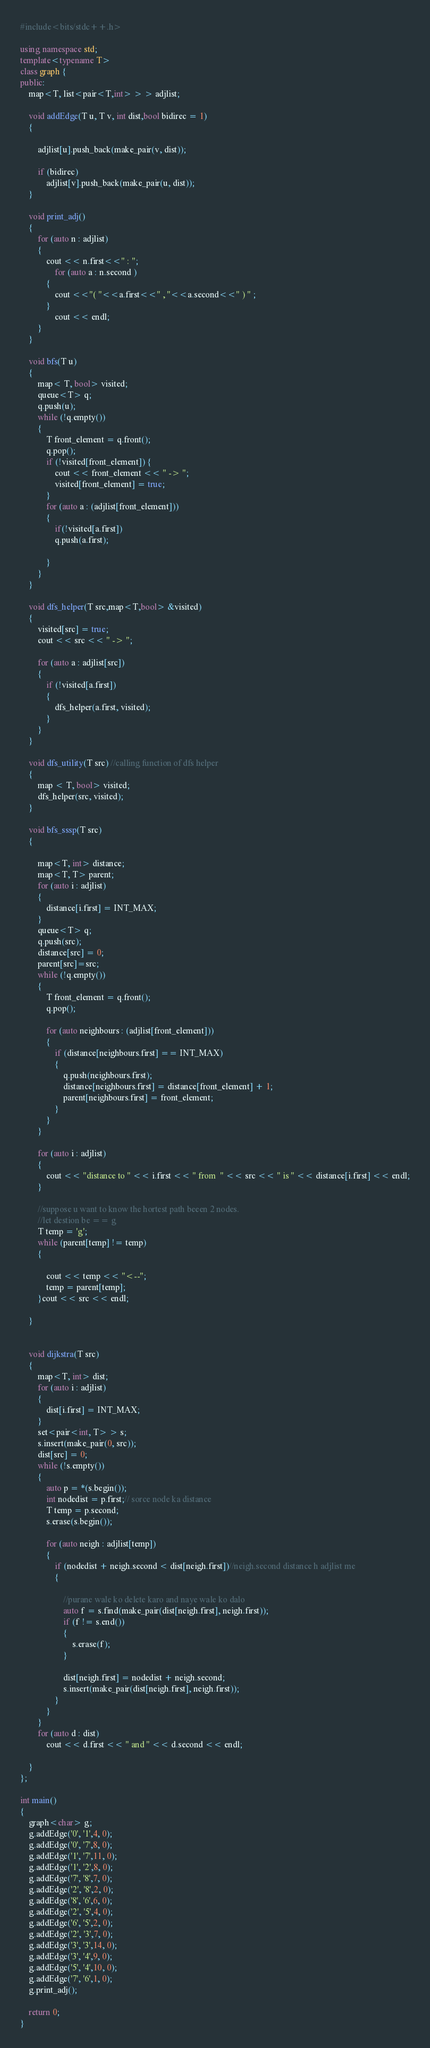<code> <loc_0><loc_0><loc_500><loc_500><_C++_>#include<bits/stdc++.h>

using namespace std;
template<typename T>
class graph {
public:
	map<T, list<pair<T,int> > > adjlist;

	void addEdge(T u, T v, int dist,bool bidirec = 1)
	{
		 
		adjlist[u].push_back(make_pair(v, dist));
		
		if (bidirec)
			adjlist[v].push_back(make_pair(u, dist));
	}

	void print_adj()
	{
		for (auto n : adjlist)
		{
			cout << n.first<<" : ";
				for (auto a : n.second )
			{
				cout <<"( "<<a.first<<" , "<<a.second<<" ) " ;
			}
				cout << endl;
		}
	}

	void bfs(T u)
	{
		map< T, bool> visited;
		queue<T> q;
		q.push(u);
		while (!q.empty())
		{
			T front_element = q.front();
			q.pop();
			if (!visited[front_element]) {
				cout << front_element << " -> ";
				visited[front_element] = true;
			}
			for (auto a : (adjlist[front_element]))
			{
				if(!visited[a.first])
				q.push(a.first);
				
			}
		}
	}

	void dfs_helper(T src,map<T,bool> &visited)
	{
		visited[src] = true;
		cout << src << " -> ";

		for (auto a : adjlist[src])
		{
			if (!visited[a.first])
			{
				dfs_helper(a.first, visited);
			}
		}
	}	
 
	void dfs_utility(T src) //calling function of dfs helper
	{
		map < T, bool> visited;
		dfs_helper(src, visited);
	}

	void bfs_sssp(T src)
	{

		map<T, int> distance;
		map<T, T> parent;
		for (auto i : adjlist)
		{
			distance[i.first] = INT_MAX;
		}
		queue<T> q;
		q.push(src);
		distance[src] = 0;
		parent[src]=src;
		while (!q.empty())
		{
			T front_element = q.front();
			q.pop();

			for (auto neighbours : (adjlist[front_element]))
			{
				if (distance[neighbours.first] == INT_MAX)
				{
					q.push(neighbours.first);
					distance[neighbours.first] = distance[front_element] + 1;
					parent[neighbours.first] = front_element;
				}
			}
		}

		for (auto i : adjlist)
		{
			cout << "distance to " << i.first << " from  " << src << " is " << distance[i.first] << endl;
		}

		//suppose u want to know the hortest path beeen 2 nodes.
		//let destion be == g
		T temp = 'g';
		while (parent[temp] != temp)
		{

			cout << temp << "<--";
			temp = parent[temp];
		}cout << src << endl;

	}


	void dijkstra(T src)
	{
		map<T, int> dist;
		for (auto i : adjlist)
		{
			dist[i.first] = INT_MAX;
		}
		set<pair<int, T> > s;
		s.insert(make_pair(0, src));
		dist[src] = 0;
		while (!s.empty())
		{
			auto p = *(s.begin());
			int nodedist = p.first;// sorce node ka distance
			T temp = p.second;
			s.erase(s.begin());

			for (auto neigh : adjlist[temp])
			{
				if (nodedist + neigh.second < dist[neigh.first])//neigh.second distance h adjlist me
				{

					//purane wale ko delete karo and naye wale ko dalo
					auto f = s.find(make_pair(dist[neigh.first], neigh.first));
					if (f != s.end())
					{
						s.erase(f);
					}

					dist[neigh.first] = nodedist + neigh.second;
					s.insert(make_pair(dist[neigh.first], neigh.first));
				}
			}
		}
		for (auto d : dist) 
			cout << d.first << " and " << d.second << endl;
		
	}
};

int main()
{
	graph<char> g;
	g.addEdge('0', '1',4, 0);
	g.addEdge('0', '7',8, 0);
	g.addEdge('1', '7',11, 0);
	g.addEdge('1', '2',8, 0);
	g.addEdge('7', '8',7, 0);
	g.addEdge('2', '8',2, 0);
	g.addEdge('8', '6',6, 0);
	g.addEdge('2', '5',4, 0);
	g.addEdge('6', '5',2, 0);
	g.addEdge('2', '3',7, 0);
	g.addEdge('3', '3',14, 0);
	g.addEdge('3', '4',9, 0);
	g.addEdge('5', '4',10, 0);
	g.addEdge('7', '6',1, 0);
	g.print_adj();
	
	return 0;
}</code> 